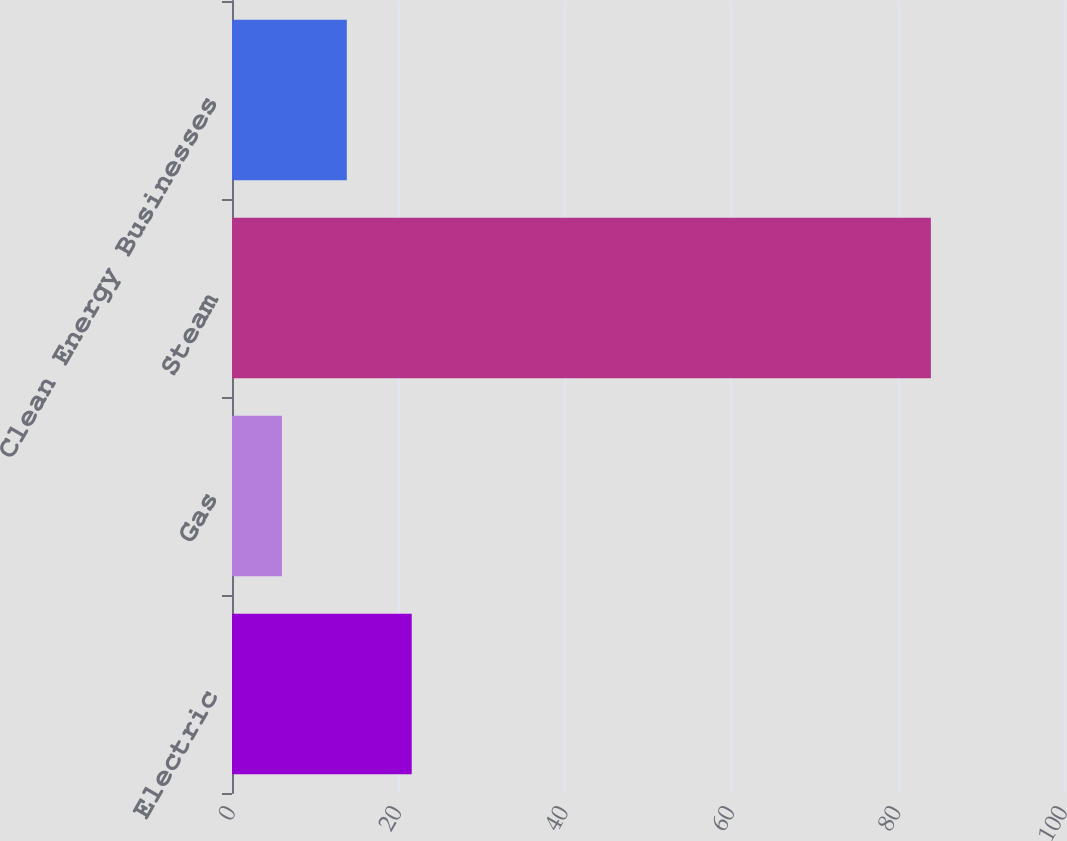Convert chart. <chart><loc_0><loc_0><loc_500><loc_500><bar_chart><fcel>Electric<fcel>Gas<fcel>Steam<fcel>Clean Energy Businesses<nl><fcel>21.6<fcel>6<fcel>84<fcel>13.8<nl></chart> 